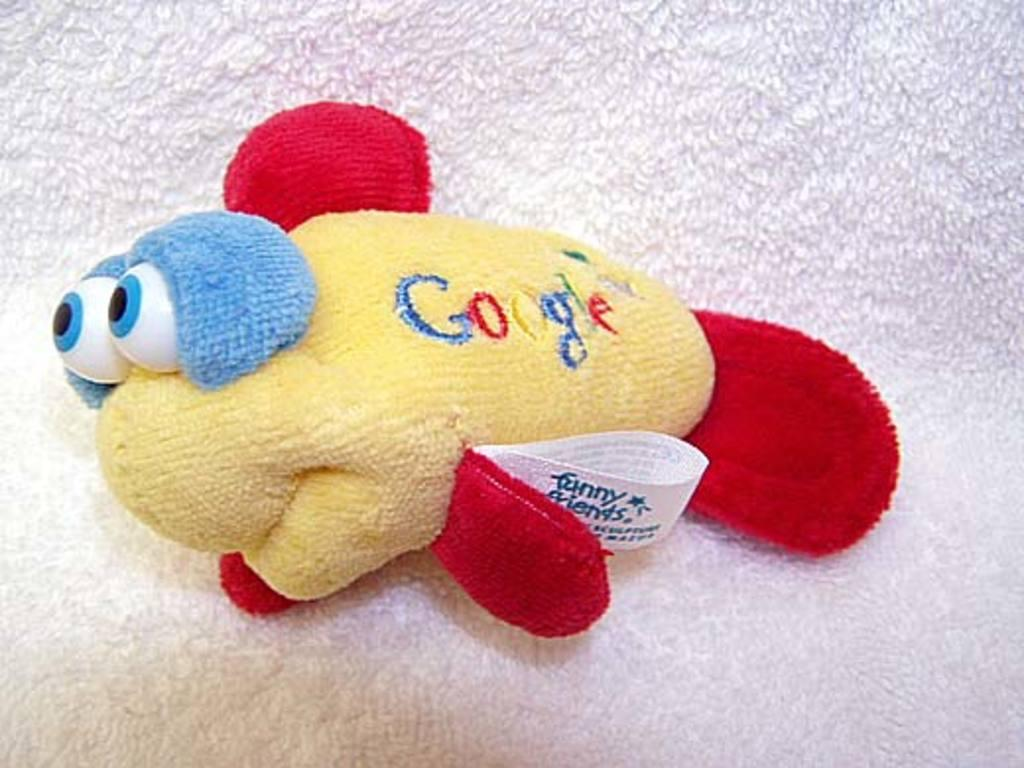What type of toy is present in the image? There is a toy of a fish in the image. What is the toy of a fish placed on? The toy of a fish is on a cloth. What type of agreement was reached regarding the low decision in the image? There is no mention of an agreement or decision in the image, as it only features a toy of a fish on a cloth. 